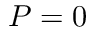<formula> <loc_0><loc_0><loc_500><loc_500>P = 0</formula> 